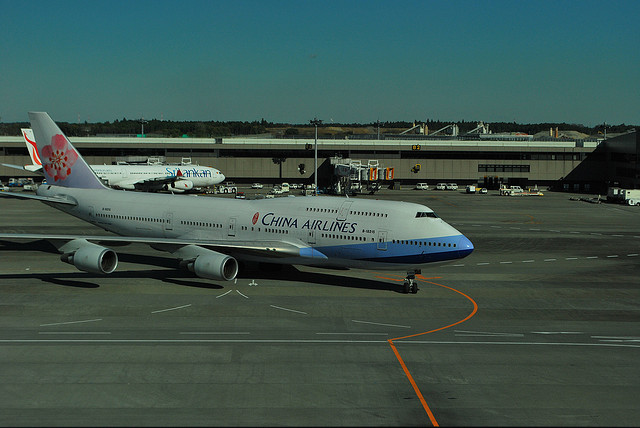Please extract the text content from this image. CHINA AIRLINES 